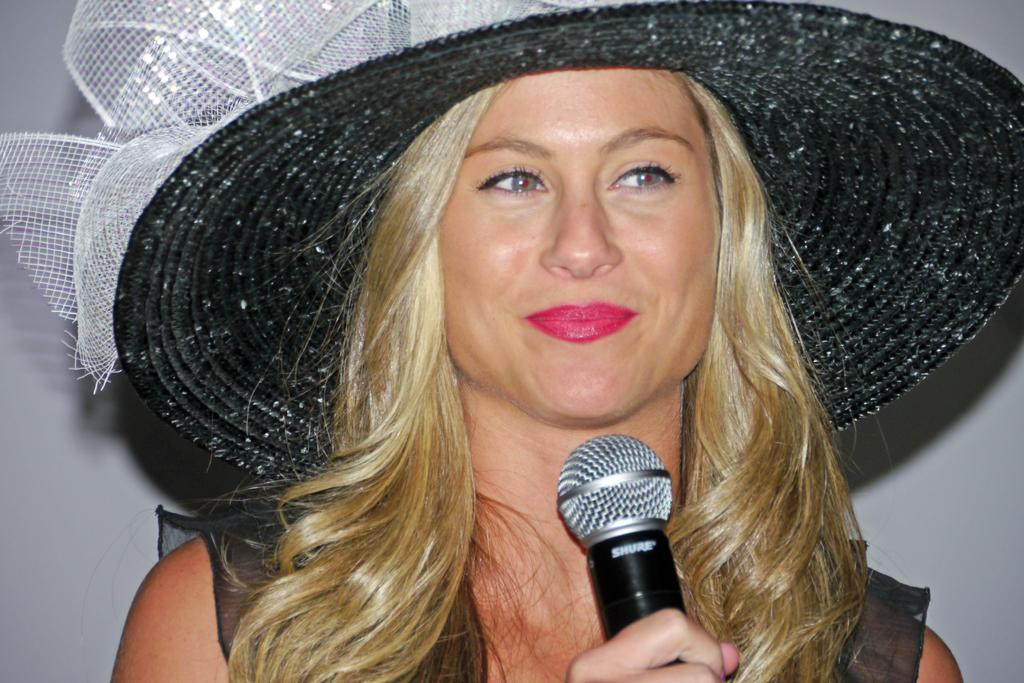Who is the main subject in the image? There is a woman in the image. What is the woman wearing on her head? The woman is wearing a hat, which is black in color. What is the woman holding in her hand? The woman is holding a microphone. How does the woman appear to be feeling in the image? The woman has a smile on her lips, suggesting she is happy or enjoying herself. What invention is the woman demonstrating in the image? There is no invention being demonstrated in the image; the woman is simply holding a microphone. Can you see any playground equipment in the background of the image? There is no playground equipment visible in the image; it only features the woman with a microphone. 